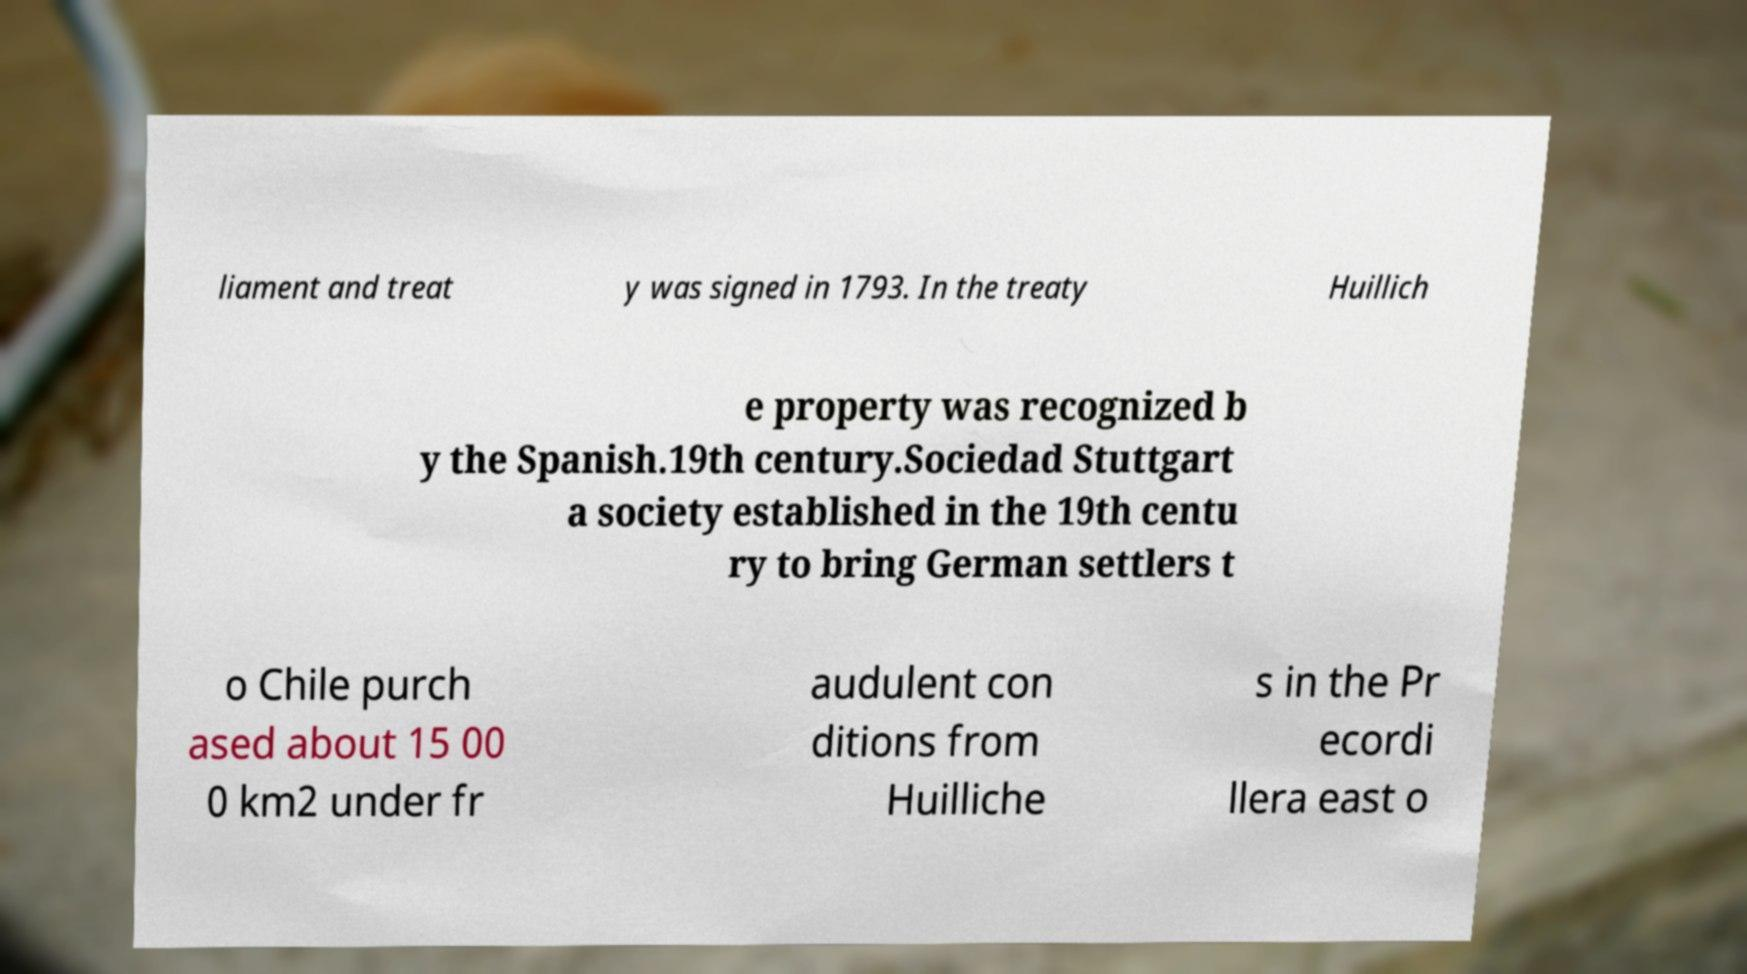I need the written content from this picture converted into text. Can you do that? liament and treat y was signed in 1793. In the treaty Huillich e property was recognized b y the Spanish.19th century.Sociedad Stuttgart a society established in the 19th centu ry to bring German settlers t o Chile purch ased about 15 00 0 km2 under fr audulent con ditions from Huilliche s in the Pr ecordi llera east o 